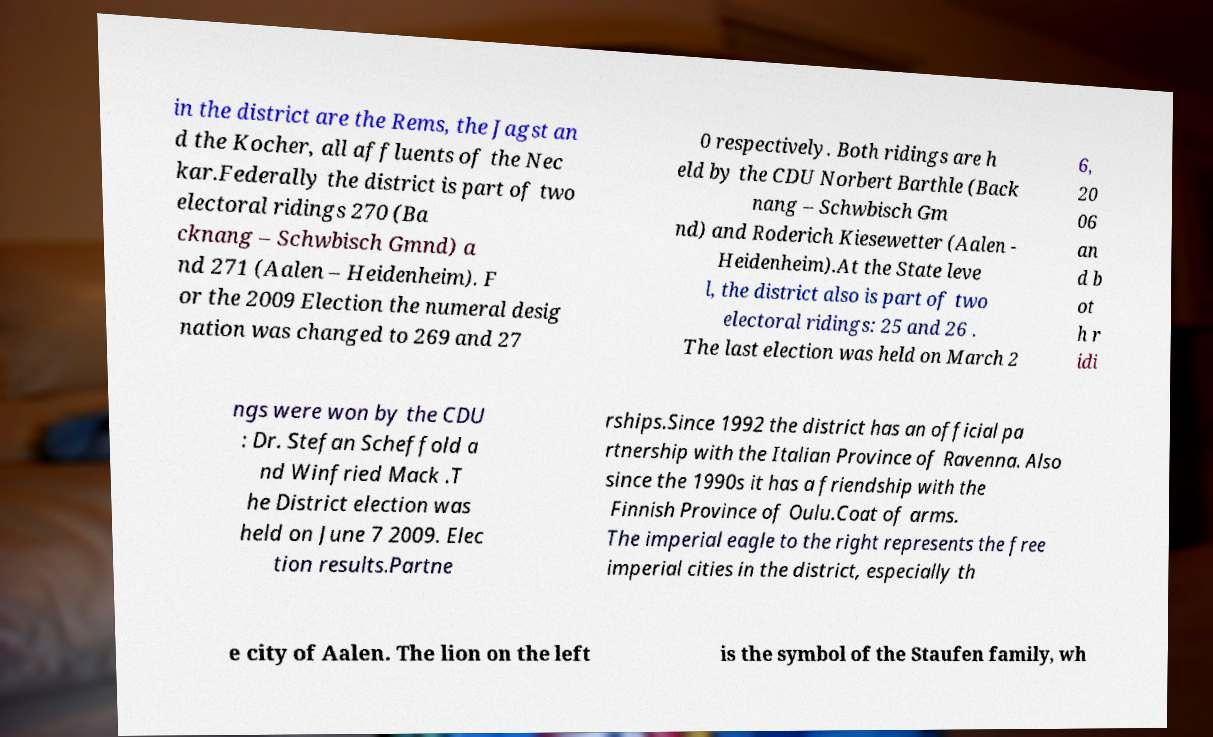Could you extract and type out the text from this image? in the district are the Rems, the Jagst an d the Kocher, all affluents of the Nec kar.Federally the district is part of two electoral ridings 270 (Ba cknang – Schwbisch Gmnd) a nd 271 (Aalen – Heidenheim). F or the 2009 Election the numeral desig nation was changed to 269 and 27 0 respectively. Both ridings are h eld by the CDU Norbert Barthle (Back nang – Schwbisch Gm nd) and Roderich Kiesewetter (Aalen - Heidenheim).At the State leve l, the district also is part of two electoral ridings: 25 and 26 . The last election was held on March 2 6, 20 06 an d b ot h r idi ngs were won by the CDU : Dr. Stefan Scheffold a nd Winfried Mack .T he District election was held on June 7 2009. Elec tion results.Partne rships.Since 1992 the district has an official pa rtnership with the Italian Province of Ravenna. Also since the 1990s it has a friendship with the Finnish Province of Oulu.Coat of arms. The imperial eagle to the right represents the free imperial cities in the district, especially th e city of Aalen. The lion on the left is the symbol of the Staufen family, wh 